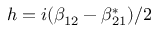<formula> <loc_0><loc_0><loc_500><loc_500>h = i ( \beta _ { 1 2 } - \beta _ { 2 1 } ^ { * } ) / 2</formula> 